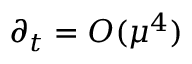<formula> <loc_0><loc_0><loc_500><loc_500>\partial _ { t } = O ( \mu ^ { 4 } )</formula> 